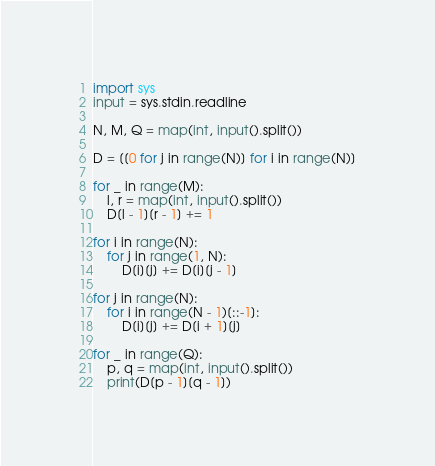<code> <loc_0><loc_0><loc_500><loc_500><_Python_>import sys
input = sys.stdin.readline

N, M, Q = map(int, input().split())

D = [[0 for j in range(N)] for i in range(N)]

for _ in range(M):
    l, r = map(int, input().split())
    D[l - 1][r - 1] += 1

for i in range(N):
    for j in range(1, N):
        D[i][j] += D[i][j - 1]

for j in range(N):
    for i in range(N - 1)[::-1]:
        D[i][j] += D[i + 1][j]

for _ in range(Q):
    p, q = map(int, input().split())
    print(D[p - 1][q - 1])</code> 